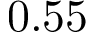<formula> <loc_0><loc_0><loc_500><loc_500>0 . 5 5</formula> 